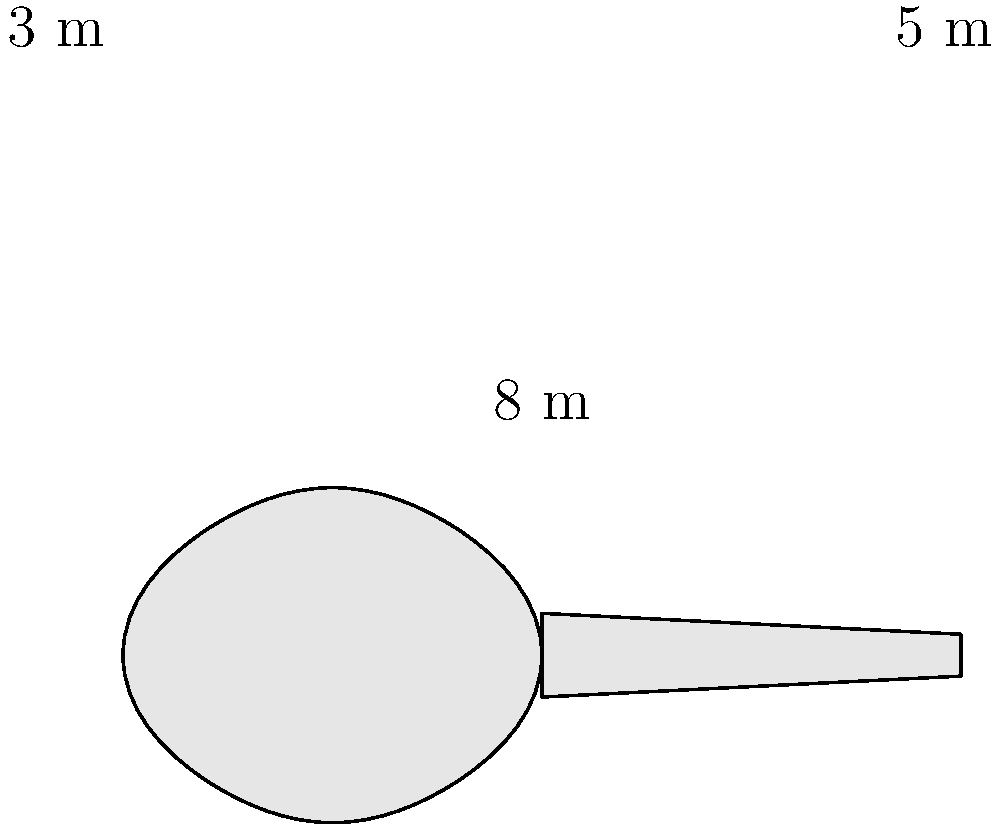In honor of our town's famous rock star, we're building a guitar-shaped auditorium for music performances. The main body of the auditorium is shaped like an ellipsoid, and the neck is a rectangular prism. The body has a length of 8 m, a width of 3 m, and a height of 2 m. The neck is 5 m long, 1 m wide, and has the same height as the body. Calculate the total volume of the auditorium in cubic meters. To calculate the total volume, we need to find the volume of the ellipsoid (body) and the rectangular prism (neck) separately, then add them together.

1. Volume of the ellipsoid (body):
   The formula for the volume of an ellipsoid is $V = \frac{4}{3}\pi abc$, where $a$, $b$, and $c$ are the semi-axes.
   
   $a = 4$ m (half of 8 m)
   $b = 1.5$ m (half of 3 m)
   $c = 1$ m (half of 2 m)

   $V_{body} = \frac{4}{3}\pi(4)(1.5)(1) = 8\pi$ cubic meters

2. Volume of the rectangular prism (neck):
   The formula for the volume of a rectangular prism is $V = l * w * h$

   $V_{neck} = 5 * 1 * 2 = 10$ cubic meters

3. Total volume:
   $V_{total} = V_{body} + V_{neck} = 8\pi + 10$ cubic meters

4. Simplifying:
   $V_{total} = 8\pi + 10 \approx 35.13$ cubic meters
Answer: $8\pi + 10 \approx 35.13$ m³ 